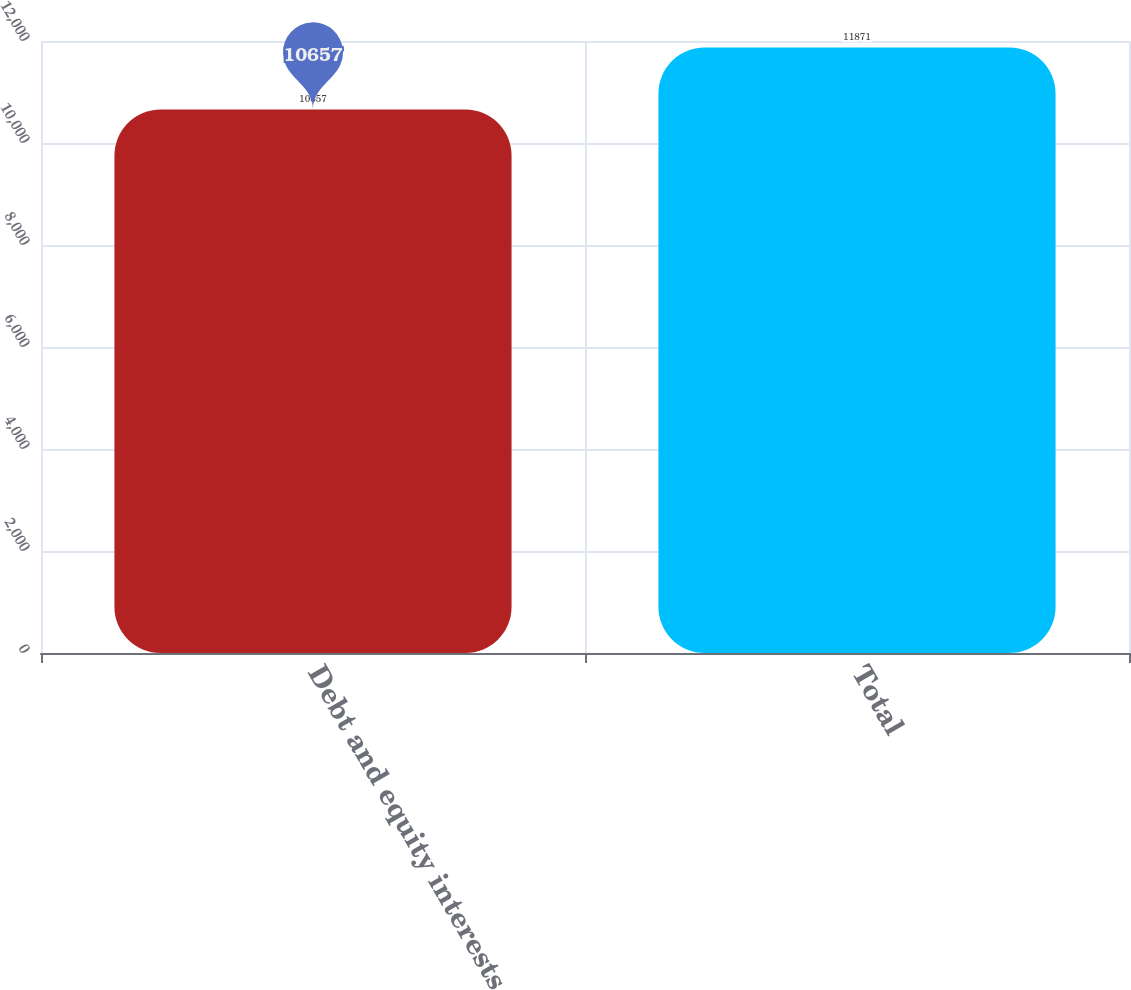<chart> <loc_0><loc_0><loc_500><loc_500><bar_chart><fcel>Debt and equity interests<fcel>Total<nl><fcel>10657<fcel>11871<nl></chart> 